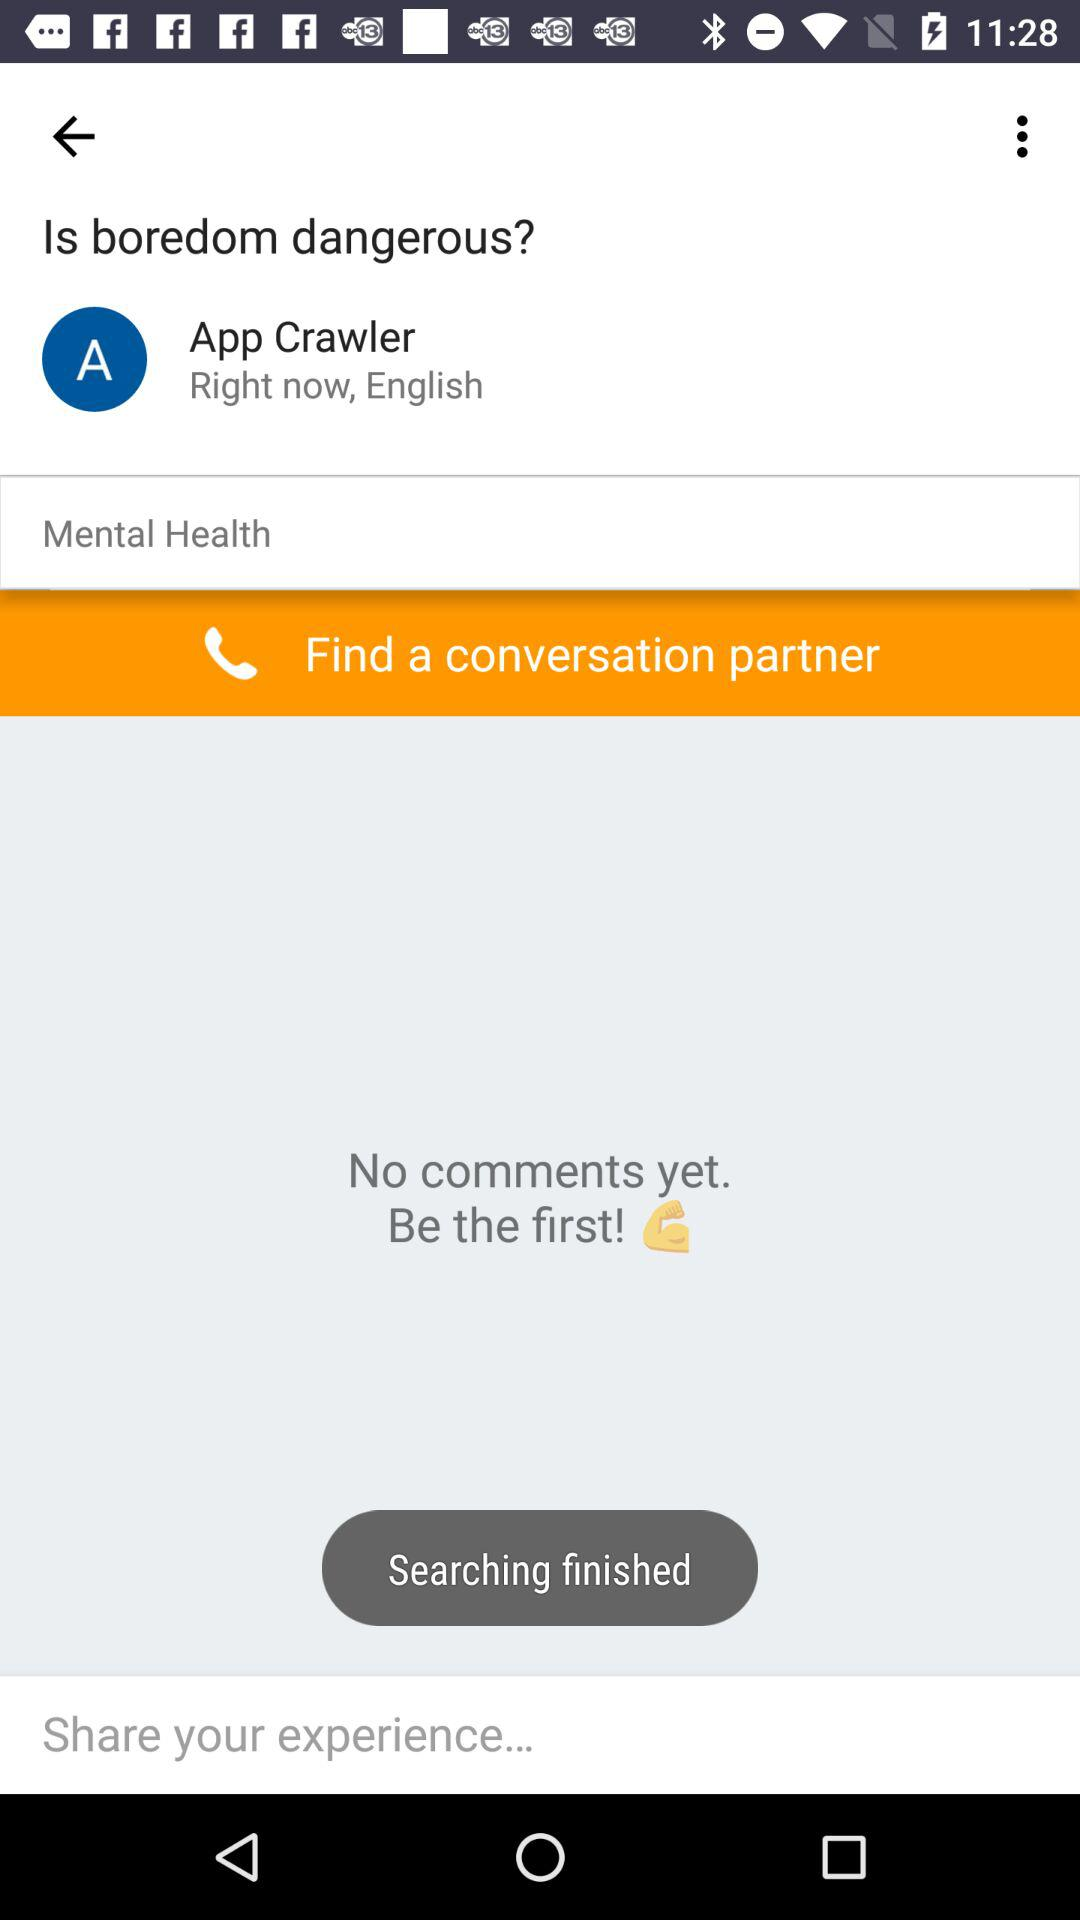How many comments are there?
Answer the question using a single word or phrase. 0 